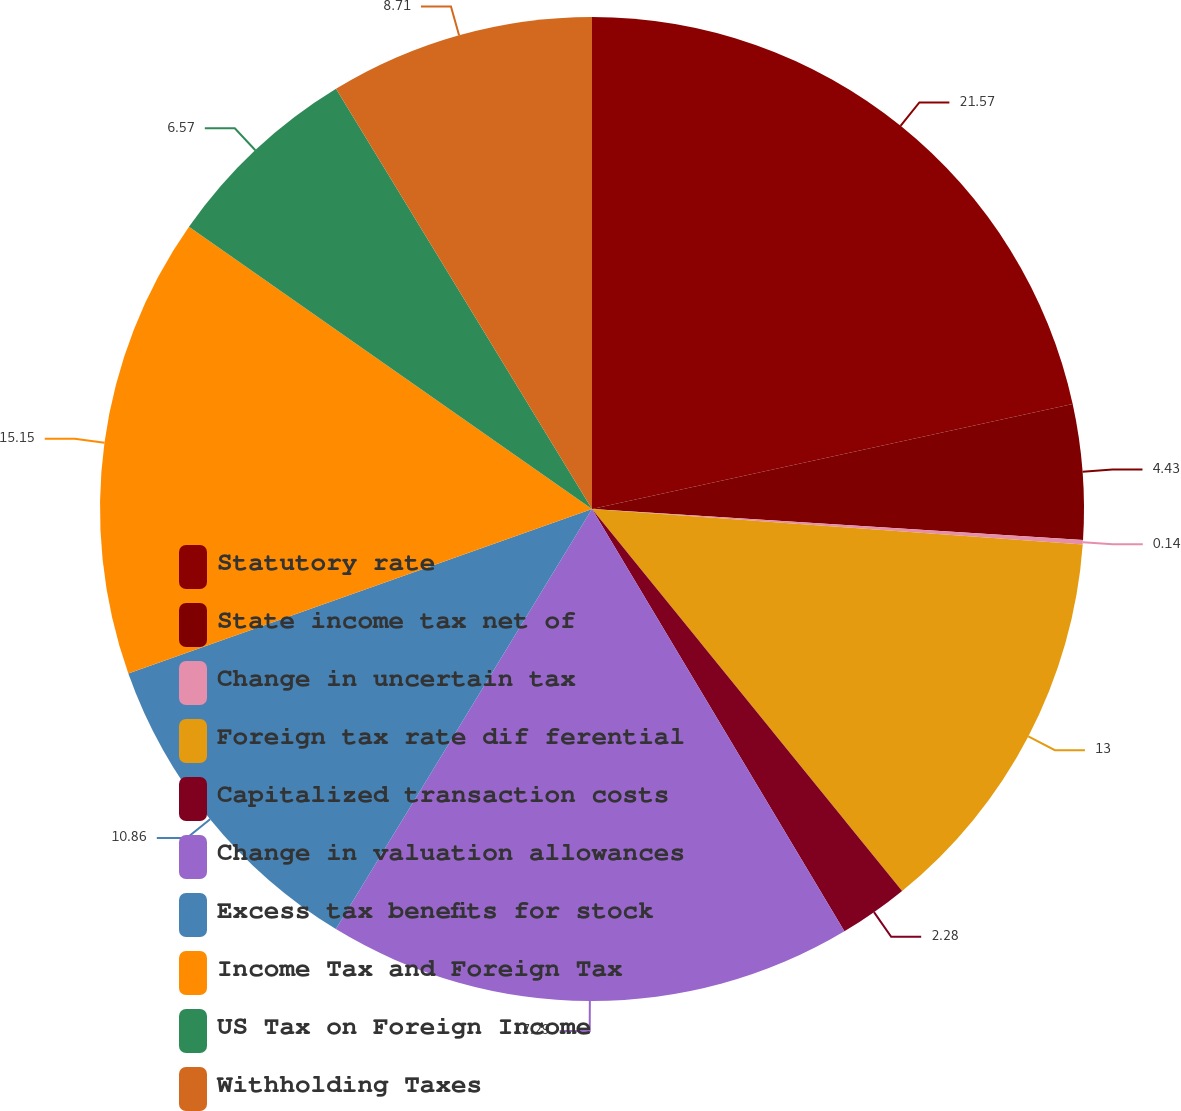Convert chart. <chart><loc_0><loc_0><loc_500><loc_500><pie_chart><fcel>Statutory rate<fcel>State income tax net of<fcel>Change in uncertain tax<fcel>Foreign tax rate dif ferential<fcel>Capitalized transaction costs<fcel>Change in valuation allowances<fcel>Excess tax benefits for stock<fcel>Income Tax and Foreign Tax<fcel>US Tax on Foreign Income<fcel>Withholding Taxes<nl><fcel>21.58%<fcel>4.43%<fcel>0.14%<fcel>13.0%<fcel>2.28%<fcel>17.29%<fcel>10.86%<fcel>15.15%<fcel>6.57%<fcel>8.71%<nl></chart> 